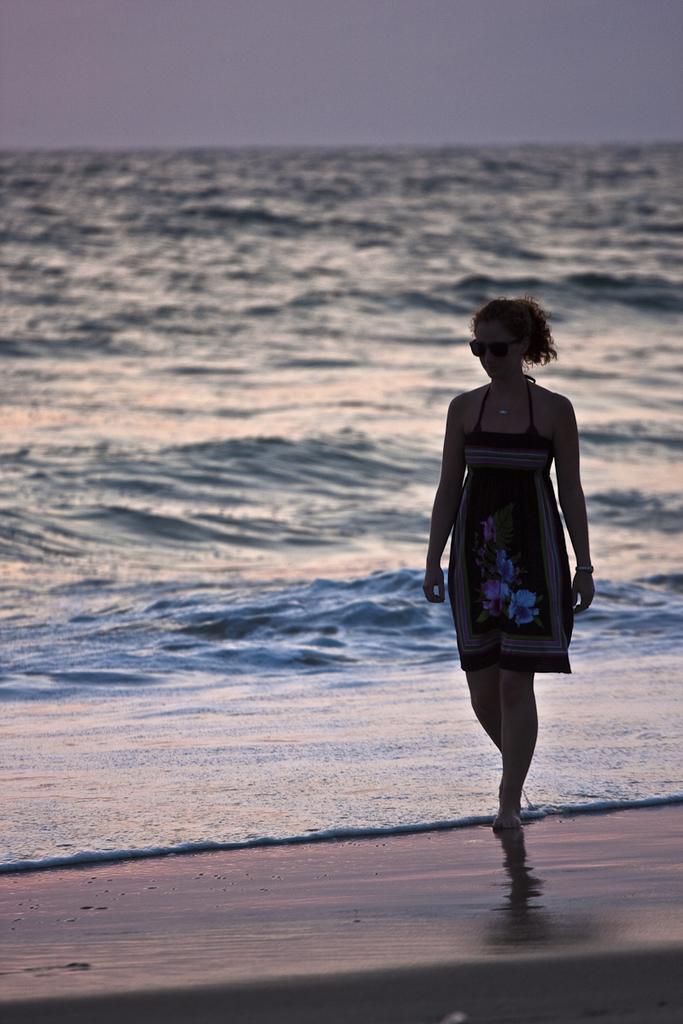Describe this image in one or two sentences. On the right side of the image we can see a lady walking on the sea shore. In the background there is a sea. 